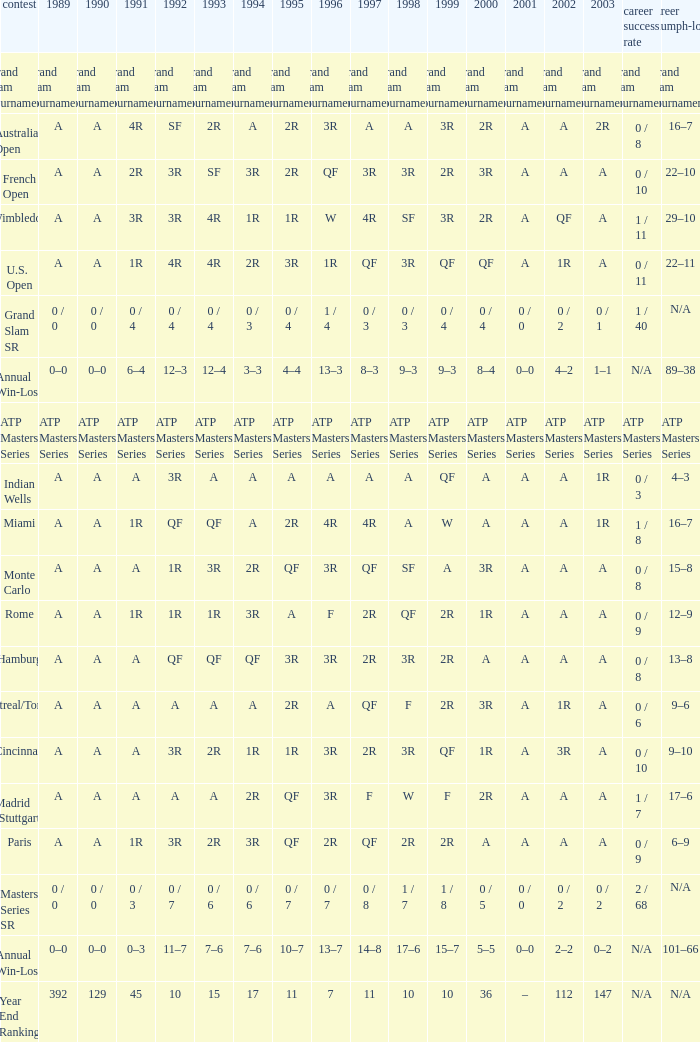What was the 1997 value when 2002 was A and 2003 was 1R? A, 4R. 